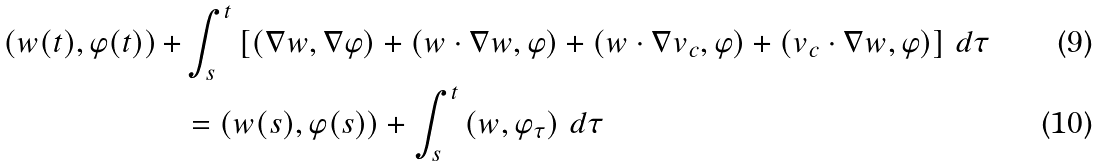Convert formula to latex. <formula><loc_0><loc_0><loc_500><loc_500>\left ( w ( t ) , \varphi ( t ) \right ) + & \int _ { s } ^ { t } \left [ \left ( \nabla w , \nabla \varphi \right ) + \left ( w \cdot \nabla w , \varphi \right ) + \left ( w \cdot \nabla v _ { c } , \varphi \right ) + \left ( v _ { c } \cdot \nabla w , \varphi \right ) \right ] \, d \tau \\ & = \left ( w ( s ) , \varphi ( s ) \right ) + \int _ { s } ^ { t } \left ( w , \varphi _ { \tau } \right ) \, d \tau</formula> 